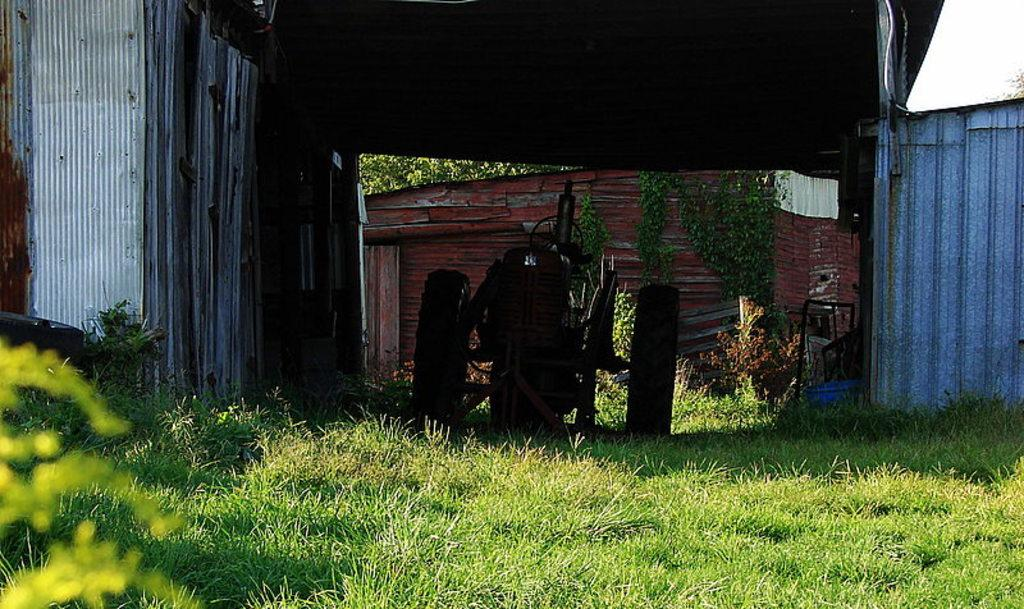What type of structure is present in the image? There is a shed in the image. What type of vehicle is visible in the image? There is a tractor in the image. What is the color and texture of the ground in the image? There is green grass in the image. What can be seen in the background of the image? There are plants in the background of the image. What type of plant is growing on a red object in the image? There are creepers on a red color object in the image. How many cars are parked next to the shed in the image? There are no cars present in the image; it features a shed, a tractor, green grass, plants in the background, and creepers on a red object. Can you see any snakes slithering through the grass in the image? There is no mention of snakes in the image, and no snakes are visible. 